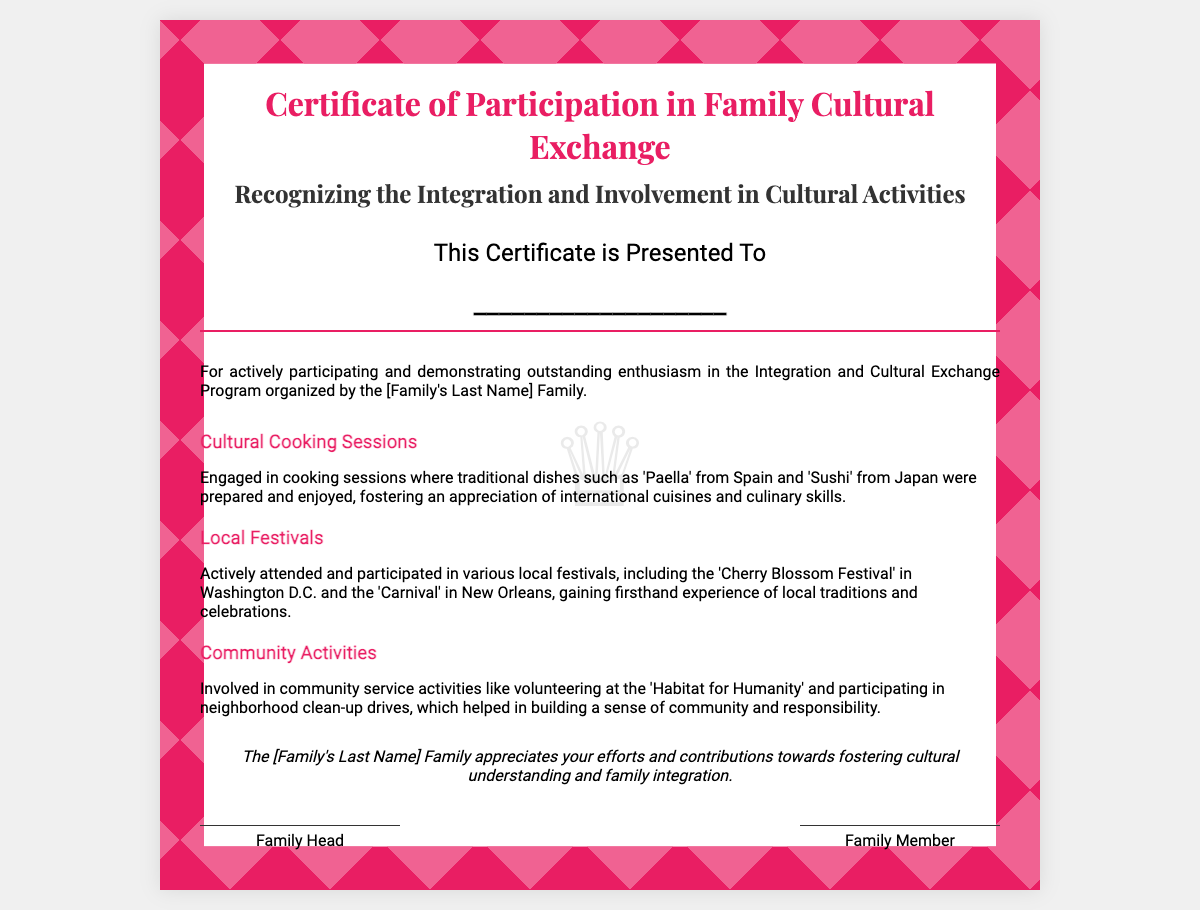What is the title of the document? The title is prominently displayed at the top of the certificate, indicating its purpose.
Answer: Certificate of Participation in Family Cultural Exchange Who is this certificate presented to? The certificate includes a section for the player's name to be written, denoting the recipient.
Answer: ____________________ What cultural dish was mentioned from Spain? The document lists specific traditional dishes that were prepared during cooking sessions, including one from Spain.
Answer: Paella What festival is referenced that takes place in Washington D.C.? The certificate describes local festivals the player participated in, one of which is specifically mentioned.
Answer: Cherry Blossom Festival What community activity is mentioned related to housing? The document outlines various community service activities the player was involved in, including one concerning housing.
Answer: Habitat for Humanity Which family member signed the certificate? The certificate has designated spaces for signatures, indicating participants in the family exchange program.
Answer: Family Head What color is the mosaic border in the certificate? The style section of the document's code indicates the color used for the mosaic border.
Answer: #e91e63 How is the player recognized for their efforts in the conclusion? The conclusion section summarizes the certificate's acknowledgment of the player's contributions.
Answer: The [Family's Last Name] Family appreciates your efforts and contributions towards fostering cultural understanding and family integration 